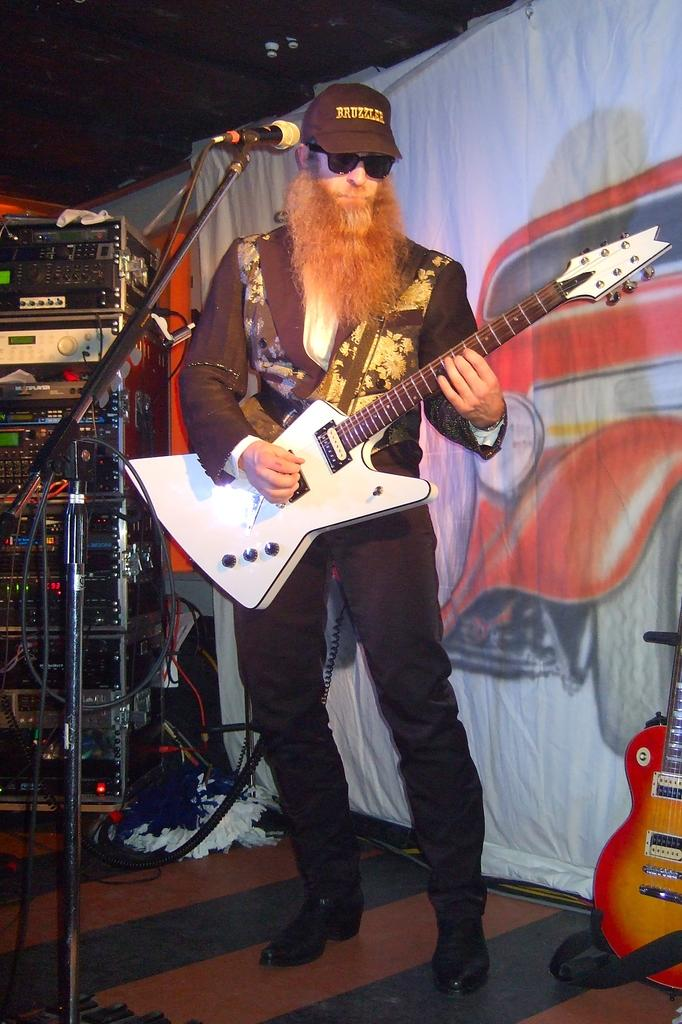What is the man in the image doing? The man is playing a guitar in the image. What else can be seen in the background of the image? There are musical instruments in the background of the image. What is the purpose of the banner in the image? The purpose of the banner in the image is not clear from the provided facts. Where is the guitar located in the image? A guitar is visible in the bottom right corner of the image. How many houses are visible in the image? There are no houses visible in the image. What type of art is the man creating while playing the guitar? The provided facts do not mention any art being created in the image. 